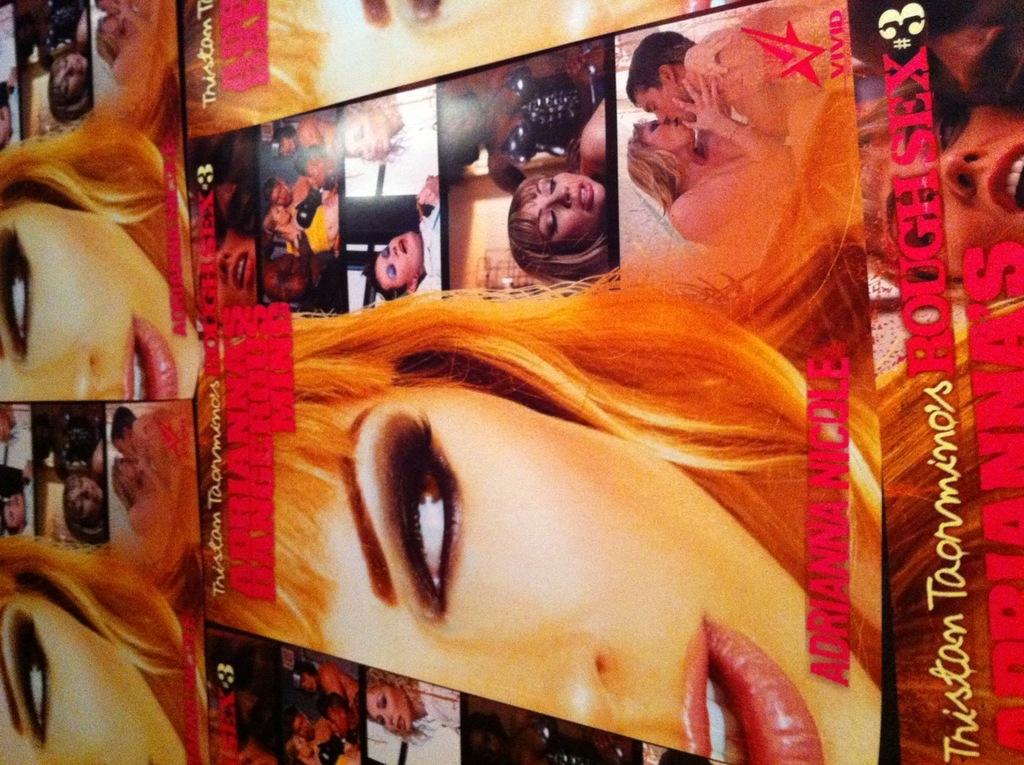What kind of sex?
Provide a short and direct response. Rough. What is the name of this actor?
Offer a very short reply. Adrianna nicole. 